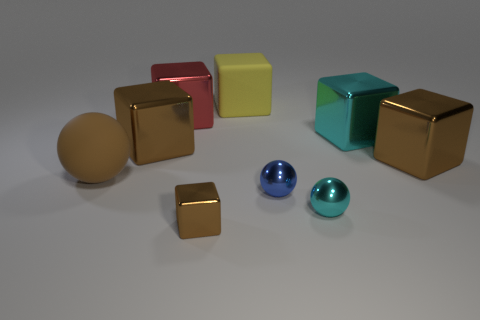How do the textures of the objects compare? The objects in the image all seem to have a smooth texture with a reflective surface. The lighting highlights their glossy finish, suggesting that each object is likely made of a material similar to polished metal or plastic. 